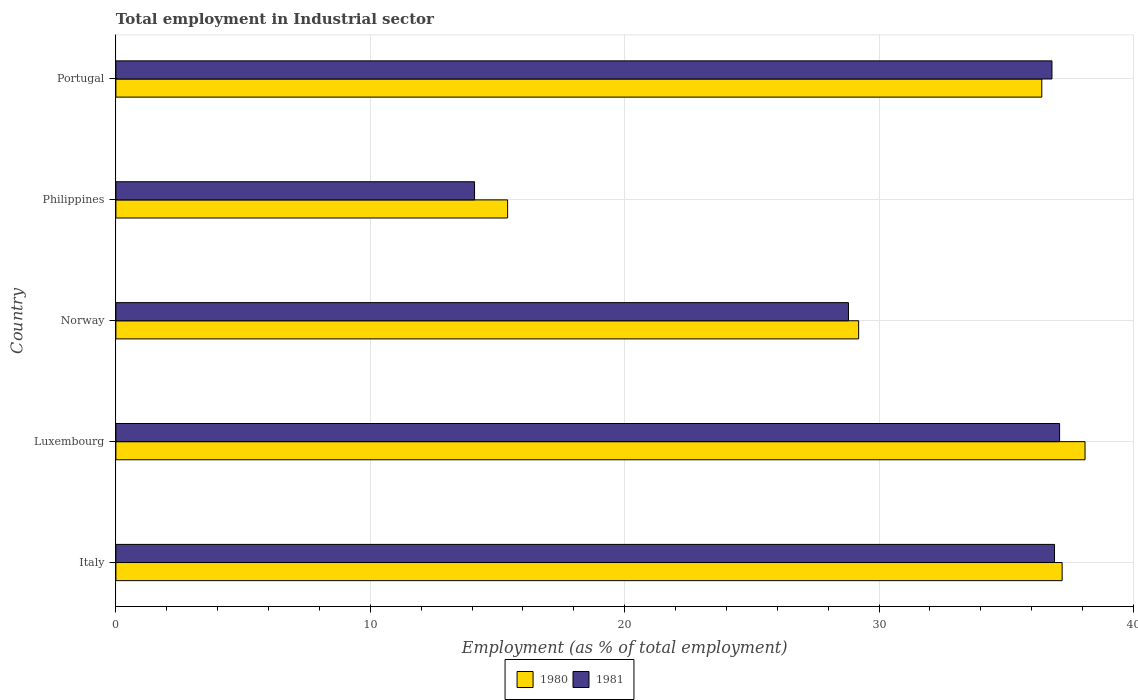How many different coloured bars are there?
Your response must be concise. 2. Are the number of bars per tick equal to the number of legend labels?
Give a very brief answer. Yes. How many bars are there on the 1st tick from the top?
Make the answer very short. 2. What is the label of the 1st group of bars from the top?
Offer a terse response. Portugal. In how many cases, is the number of bars for a given country not equal to the number of legend labels?
Your answer should be compact. 0. What is the employment in industrial sector in 1981 in Portugal?
Keep it short and to the point. 36.8. Across all countries, what is the maximum employment in industrial sector in 1981?
Offer a terse response. 37.1. Across all countries, what is the minimum employment in industrial sector in 1980?
Offer a terse response. 15.4. In which country was the employment in industrial sector in 1980 maximum?
Provide a short and direct response. Luxembourg. What is the total employment in industrial sector in 1981 in the graph?
Offer a terse response. 153.7. What is the difference between the employment in industrial sector in 1981 in Luxembourg and that in Philippines?
Your answer should be compact. 23. What is the difference between the employment in industrial sector in 1981 in Portugal and the employment in industrial sector in 1980 in Italy?
Your answer should be very brief. -0.4. What is the average employment in industrial sector in 1980 per country?
Your response must be concise. 31.26. What is the difference between the employment in industrial sector in 1980 and employment in industrial sector in 1981 in Portugal?
Make the answer very short. -0.4. What is the ratio of the employment in industrial sector in 1981 in Italy to that in Philippines?
Ensure brevity in your answer.  2.62. What is the difference between the highest and the second highest employment in industrial sector in 1980?
Offer a very short reply. 0.9. What is the difference between the highest and the lowest employment in industrial sector in 1980?
Give a very brief answer. 22.7. In how many countries, is the employment in industrial sector in 1980 greater than the average employment in industrial sector in 1980 taken over all countries?
Provide a short and direct response. 3. Are all the bars in the graph horizontal?
Provide a short and direct response. Yes. Does the graph contain any zero values?
Make the answer very short. No. How many legend labels are there?
Provide a succinct answer. 2. How are the legend labels stacked?
Keep it short and to the point. Horizontal. What is the title of the graph?
Give a very brief answer. Total employment in Industrial sector. What is the label or title of the X-axis?
Your answer should be compact. Employment (as % of total employment). What is the label or title of the Y-axis?
Give a very brief answer. Country. What is the Employment (as % of total employment) of 1980 in Italy?
Your answer should be compact. 37.2. What is the Employment (as % of total employment) of 1981 in Italy?
Give a very brief answer. 36.9. What is the Employment (as % of total employment) in 1980 in Luxembourg?
Your response must be concise. 38.1. What is the Employment (as % of total employment) in 1981 in Luxembourg?
Provide a succinct answer. 37.1. What is the Employment (as % of total employment) in 1980 in Norway?
Make the answer very short. 29.2. What is the Employment (as % of total employment) in 1981 in Norway?
Give a very brief answer. 28.8. What is the Employment (as % of total employment) in 1980 in Philippines?
Keep it short and to the point. 15.4. What is the Employment (as % of total employment) in 1981 in Philippines?
Keep it short and to the point. 14.1. What is the Employment (as % of total employment) in 1980 in Portugal?
Offer a very short reply. 36.4. What is the Employment (as % of total employment) in 1981 in Portugal?
Make the answer very short. 36.8. Across all countries, what is the maximum Employment (as % of total employment) in 1980?
Provide a short and direct response. 38.1. Across all countries, what is the maximum Employment (as % of total employment) of 1981?
Make the answer very short. 37.1. Across all countries, what is the minimum Employment (as % of total employment) in 1980?
Offer a terse response. 15.4. Across all countries, what is the minimum Employment (as % of total employment) of 1981?
Your answer should be very brief. 14.1. What is the total Employment (as % of total employment) of 1980 in the graph?
Your answer should be very brief. 156.3. What is the total Employment (as % of total employment) in 1981 in the graph?
Offer a terse response. 153.7. What is the difference between the Employment (as % of total employment) in 1981 in Italy and that in Luxembourg?
Keep it short and to the point. -0.2. What is the difference between the Employment (as % of total employment) of 1981 in Italy and that in Norway?
Give a very brief answer. 8.1. What is the difference between the Employment (as % of total employment) in 1980 in Italy and that in Philippines?
Offer a terse response. 21.8. What is the difference between the Employment (as % of total employment) of 1981 in Italy and that in Philippines?
Ensure brevity in your answer.  22.8. What is the difference between the Employment (as % of total employment) of 1980 in Italy and that in Portugal?
Provide a short and direct response. 0.8. What is the difference between the Employment (as % of total employment) of 1980 in Luxembourg and that in Norway?
Give a very brief answer. 8.9. What is the difference between the Employment (as % of total employment) in 1981 in Luxembourg and that in Norway?
Make the answer very short. 8.3. What is the difference between the Employment (as % of total employment) of 1980 in Luxembourg and that in Philippines?
Your answer should be compact. 22.7. What is the difference between the Employment (as % of total employment) of 1981 in Luxembourg and that in Portugal?
Give a very brief answer. 0.3. What is the difference between the Employment (as % of total employment) in 1981 in Norway and that in Philippines?
Your answer should be very brief. 14.7. What is the difference between the Employment (as % of total employment) of 1981 in Norway and that in Portugal?
Your response must be concise. -8. What is the difference between the Employment (as % of total employment) of 1981 in Philippines and that in Portugal?
Ensure brevity in your answer.  -22.7. What is the difference between the Employment (as % of total employment) in 1980 in Italy and the Employment (as % of total employment) in 1981 in Philippines?
Offer a very short reply. 23.1. What is the difference between the Employment (as % of total employment) in 1980 in Luxembourg and the Employment (as % of total employment) in 1981 in Norway?
Keep it short and to the point. 9.3. What is the difference between the Employment (as % of total employment) of 1980 in Norway and the Employment (as % of total employment) of 1981 in Philippines?
Offer a very short reply. 15.1. What is the difference between the Employment (as % of total employment) in 1980 in Philippines and the Employment (as % of total employment) in 1981 in Portugal?
Provide a succinct answer. -21.4. What is the average Employment (as % of total employment) of 1980 per country?
Your answer should be very brief. 31.26. What is the average Employment (as % of total employment) in 1981 per country?
Offer a terse response. 30.74. What is the difference between the Employment (as % of total employment) of 1980 and Employment (as % of total employment) of 1981 in Italy?
Make the answer very short. 0.3. What is the difference between the Employment (as % of total employment) of 1980 and Employment (as % of total employment) of 1981 in Luxembourg?
Provide a short and direct response. 1. What is the difference between the Employment (as % of total employment) in 1980 and Employment (as % of total employment) in 1981 in Portugal?
Your answer should be compact. -0.4. What is the ratio of the Employment (as % of total employment) of 1980 in Italy to that in Luxembourg?
Keep it short and to the point. 0.98. What is the ratio of the Employment (as % of total employment) of 1981 in Italy to that in Luxembourg?
Give a very brief answer. 0.99. What is the ratio of the Employment (as % of total employment) of 1980 in Italy to that in Norway?
Keep it short and to the point. 1.27. What is the ratio of the Employment (as % of total employment) in 1981 in Italy to that in Norway?
Ensure brevity in your answer.  1.28. What is the ratio of the Employment (as % of total employment) in 1980 in Italy to that in Philippines?
Ensure brevity in your answer.  2.42. What is the ratio of the Employment (as % of total employment) in 1981 in Italy to that in Philippines?
Give a very brief answer. 2.62. What is the ratio of the Employment (as % of total employment) in 1980 in Italy to that in Portugal?
Give a very brief answer. 1.02. What is the ratio of the Employment (as % of total employment) of 1980 in Luxembourg to that in Norway?
Ensure brevity in your answer.  1.3. What is the ratio of the Employment (as % of total employment) in 1981 in Luxembourg to that in Norway?
Offer a very short reply. 1.29. What is the ratio of the Employment (as % of total employment) of 1980 in Luxembourg to that in Philippines?
Your response must be concise. 2.47. What is the ratio of the Employment (as % of total employment) of 1981 in Luxembourg to that in Philippines?
Offer a terse response. 2.63. What is the ratio of the Employment (as % of total employment) in 1980 in Luxembourg to that in Portugal?
Offer a terse response. 1.05. What is the ratio of the Employment (as % of total employment) of 1981 in Luxembourg to that in Portugal?
Your answer should be compact. 1.01. What is the ratio of the Employment (as % of total employment) of 1980 in Norway to that in Philippines?
Your answer should be compact. 1.9. What is the ratio of the Employment (as % of total employment) in 1981 in Norway to that in Philippines?
Ensure brevity in your answer.  2.04. What is the ratio of the Employment (as % of total employment) of 1980 in Norway to that in Portugal?
Make the answer very short. 0.8. What is the ratio of the Employment (as % of total employment) of 1981 in Norway to that in Portugal?
Provide a succinct answer. 0.78. What is the ratio of the Employment (as % of total employment) of 1980 in Philippines to that in Portugal?
Keep it short and to the point. 0.42. What is the ratio of the Employment (as % of total employment) in 1981 in Philippines to that in Portugal?
Offer a very short reply. 0.38. What is the difference between the highest and the second highest Employment (as % of total employment) in 1981?
Your answer should be compact. 0.2. What is the difference between the highest and the lowest Employment (as % of total employment) of 1980?
Keep it short and to the point. 22.7. 